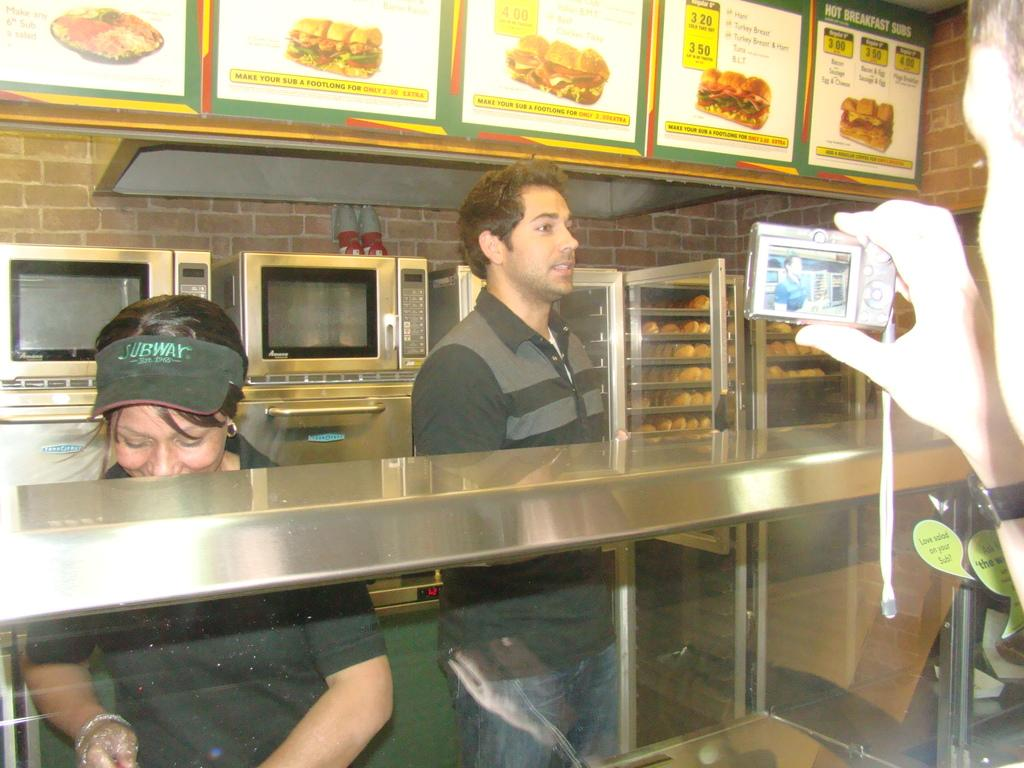<image>
Offer a succinct explanation of the picture presented. Subway employees having their pictures taken while working. 